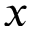<formula> <loc_0><loc_0><loc_500><loc_500>x</formula> 